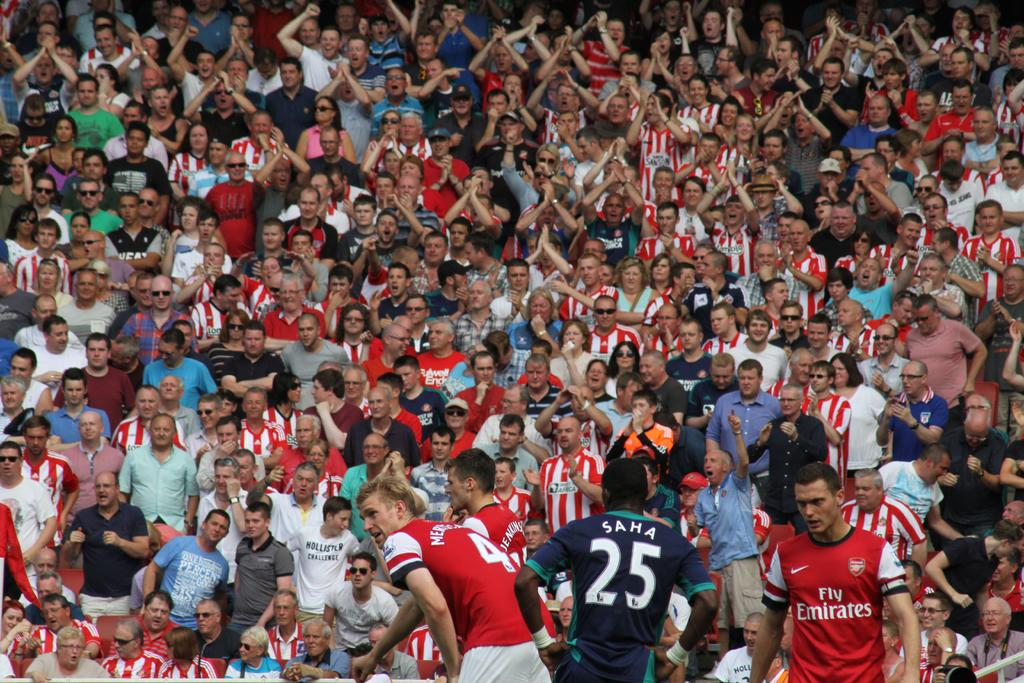What is the main subject of the image? The main subject of the image is a crowd. Where is the image taken? The image is taken in a stadium. Can you determine the time of day based on the image? The image is likely taken during the day, as there is no indication of darkness or artificial lighting. What type of cow can be seen in the image? There is no cow present in the image; it features a crowd in a stadium. What advertisement is displayed on the stadium wall in the image? There is no advertisement visible in the image; it only shows a crowd in a stadium. 